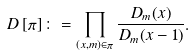Convert formula to latex. <formula><loc_0><loc_0><loc_500><loc_500>D \left [ \pi \right ] \colon = \prod _ { ( x , m ) \in \pi } \frac { D _ { m } ( x ) } { D _ { m } ( x - 1 ) } .</formula> 